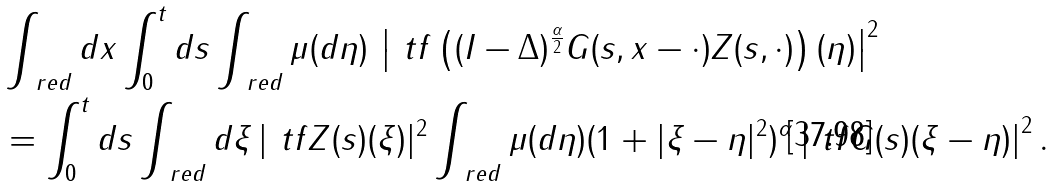<formula> <loc_0><loc_0><loc_500><loc_500>& \int _ { \ r e d } d x \int _ { 0 } ^ { t } d s \int _ { \ r e d } \mu ( d \eta ) \, \left | \ t f \left ( ( I - \Delta ) ^ { \frac { \alpha } { 2 } } G ( s , x - \cdot ) Z ( s , \cdot ) \right ) ( \eta ) \right | ^ { 2 } \\ & = \int _ { 0 } ^ { t } d s \int _ { \ r e d } d \xi \, | \ t f Z ( s ) ( \xi ) | ^ { 2 } \int _ { \ r e d } \mu ( d \eta ) ( 1 + | \xi - \eta | ^ { 2 } ) ^ { \alpha } \left | \ t f G ( s ) ( \xi - \eta ) \right | ^ { 2 } .</formula> 